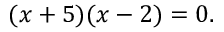Convert formula to latex. <formula><loc_0><loc_0><loc_500><loc_500>( x + 5 ) ( x - 2 ) = 0 .</formula> 